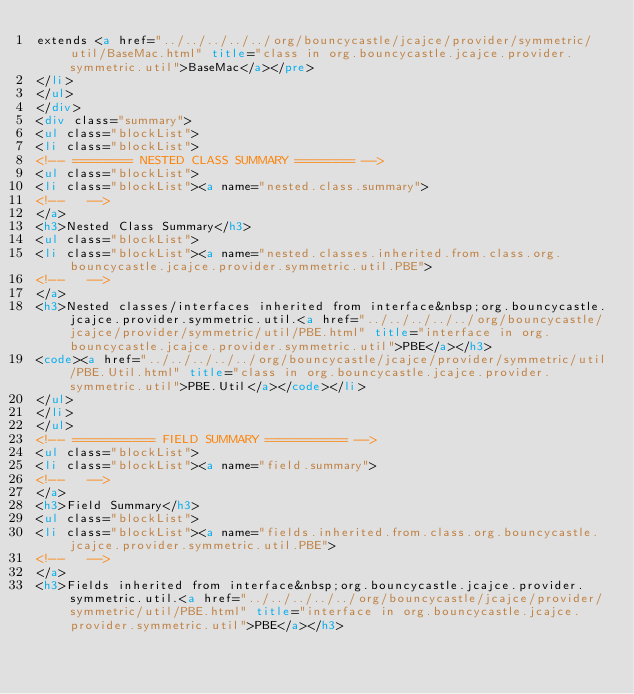<code> <loc_0><loc_0><loc_500><loc_500><_HTML_>extends <a href="../../../../../org/bouncycastle/jcajce/provider/symmetric/util/BaseMac.html" title="class in org.bouncycastle.jcajce.provider.symmetric.util">BaseMac</a></pre>
</li>
</ul>
</div>
<div class="summary">
<ul class="blockList">
<li class="blockList">
<!-- ======== NESTED CLASS SUMMARY ======== -->
<ul class="blockList">
<li class="blockList"><a name="nested.class.summary">
<!--   -->
</a>
<h3>Nested Class Summary</h3>
<ul class="blockList">
<li class="blockList"><a name="nested.classes.inherited.from.class.org.bouncycastle.jcajce.provider.symmetric.util.PBE">
<!--   -->
</a>
<h3>Nested classes/interfaces inherited from interface&nbsp;org.bouncycastle.jcajce.provider.symmetric.util.<a href="../../../../../org/bouncycastle/jcajce/provider/symmetric/util/PBE.html" title="interface in org.bouncycastle.jcajce.provider.symmetric.util">PBE</a></h3>
<code><a href="../../../../../org/bouncycastle/jcajce/provider/symmetric/util/PBE.Util.html" title="class in org.bouncycastle.jcajce.provider.symmetric.util">PBE.Util</a></code></li>
</ul>
</li>
</ul>
<!-- =========== FIELD SUMMARY =========== -->
<ul class="blockList">
<li class="blockList"><a name="field.summary">
<!--   -->
</a>
<h3>Field Summary</h3>
<ul class="blockList">
<li class="blockList"><a name="fields.inherited.from.class.org.bouncycastle.jcajce.provider.symmetric.util.PBE">
<!--   -->
</a>
<h3>Fields inherited from interface&nbsp;org.bouncycastle.jcajce.provider.symmetric.util.<a href="../../../../../org/bouncycastle/jcajce/provider/symmetric/util/PBE.html" title="interface in org.bouncycastle.jcajce.provider.symmetric.util">PBE</a></h3></code> 